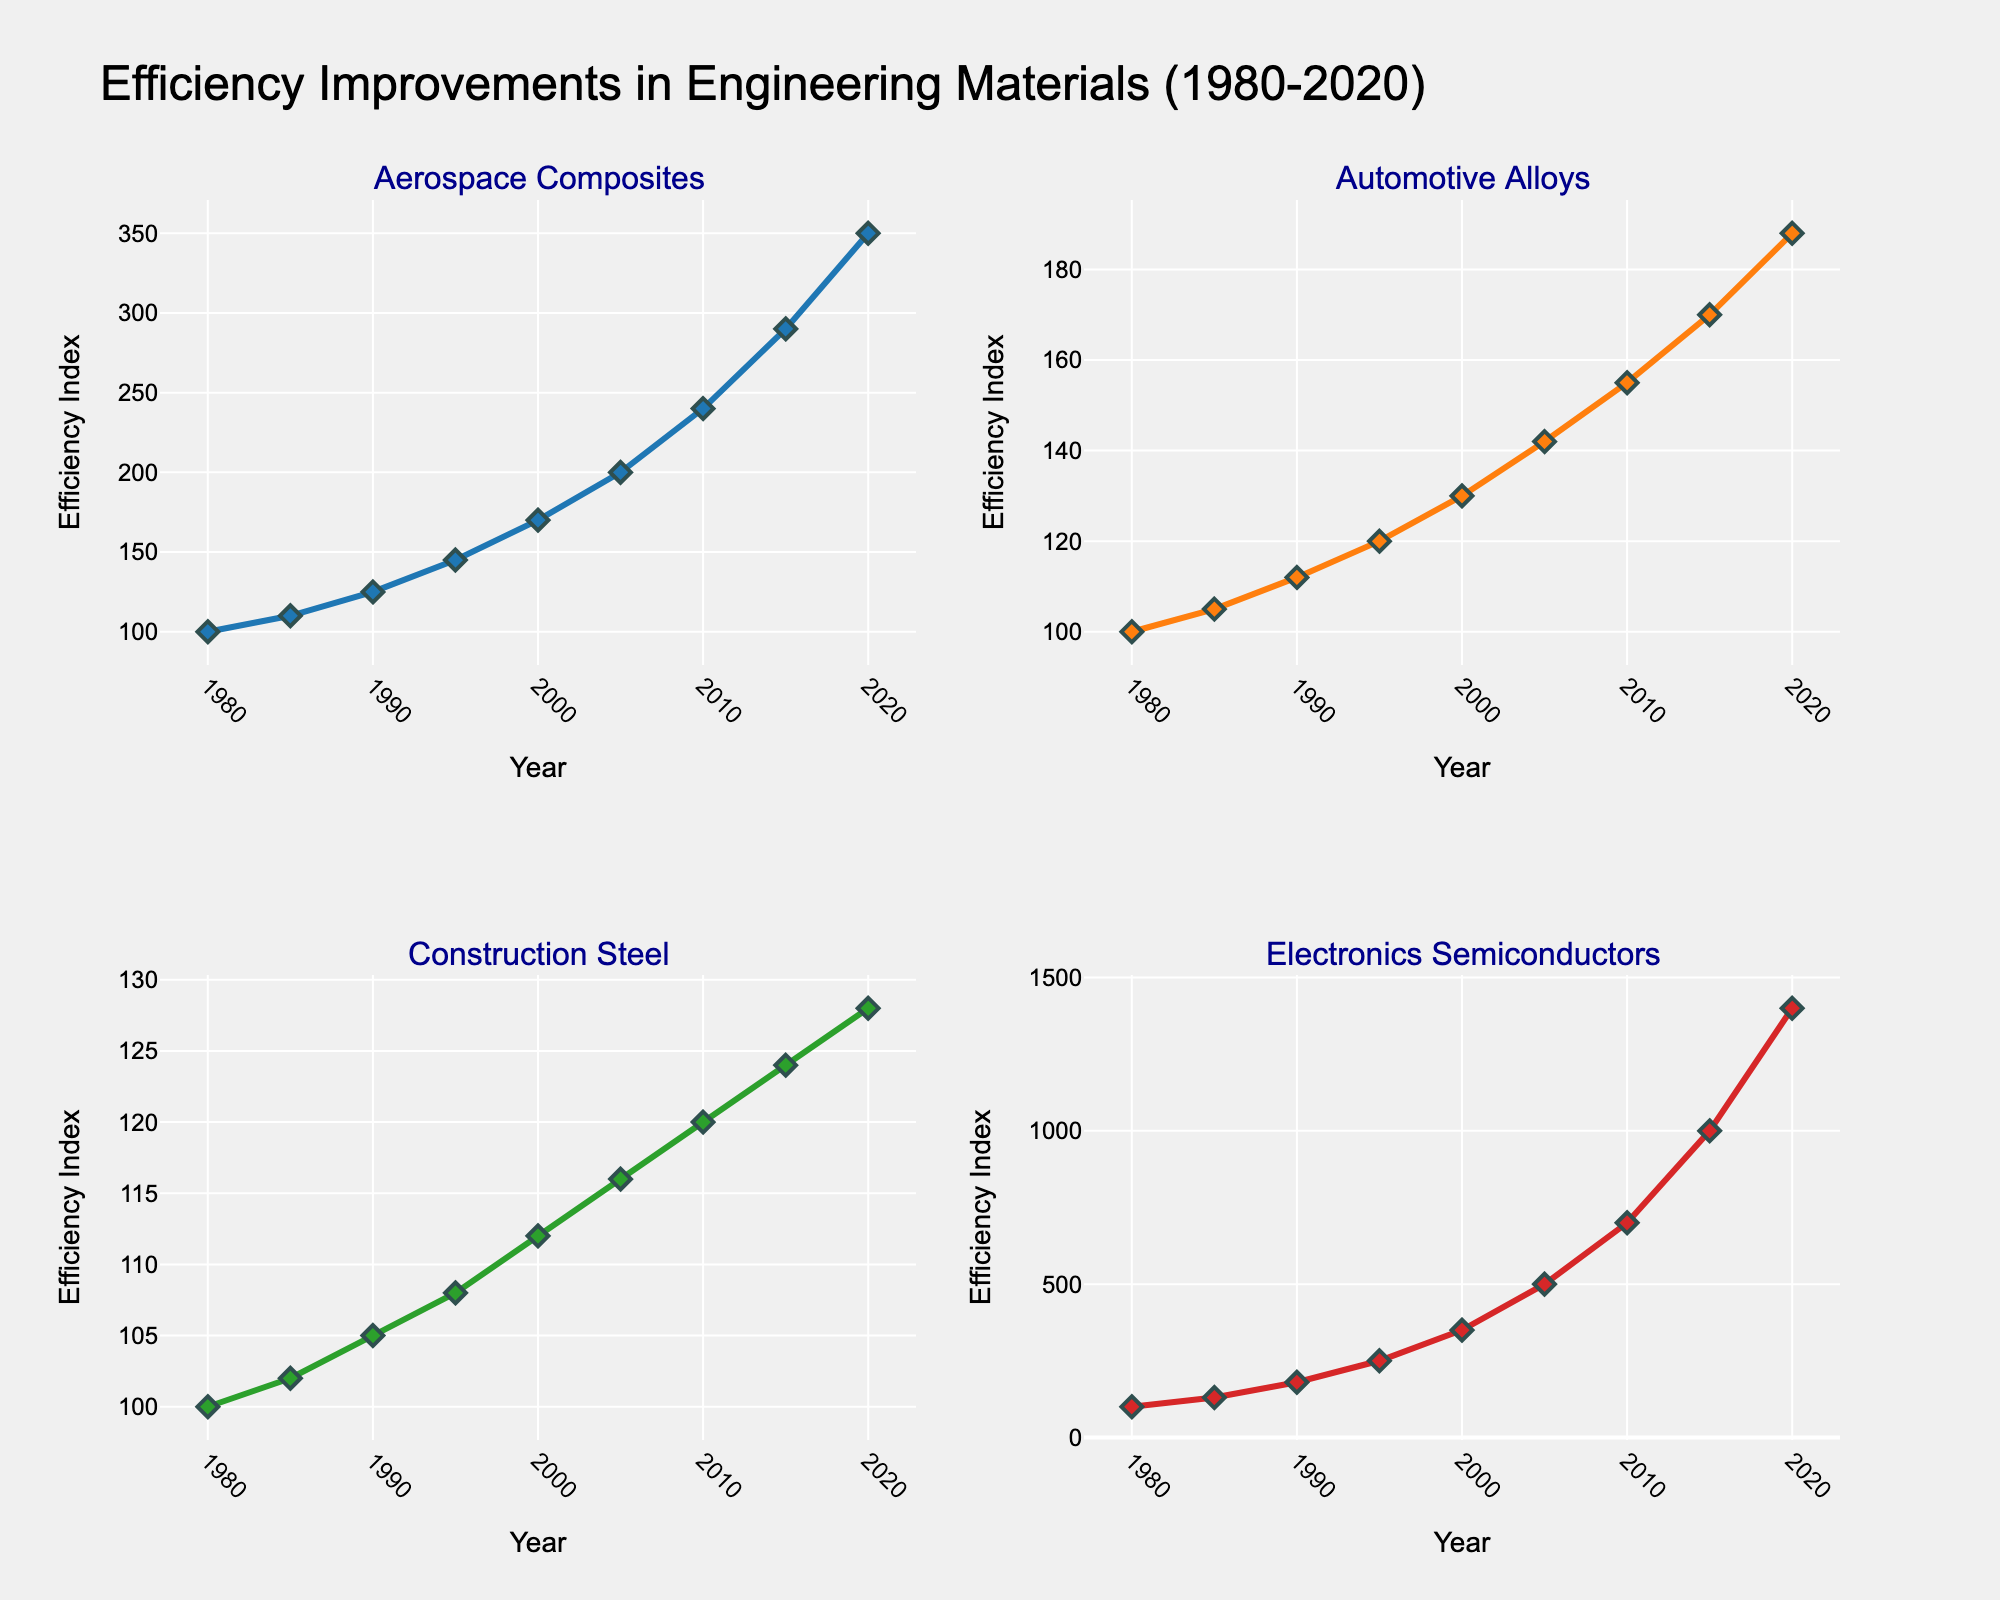What's the title of the figure? The title is usually located at the top-center of the figure. By looking at the figure's top, you can read the text that states the main topic of the chart.
Answer: Efficiency Improvements in Engineering Materials (1980-2020) How many subplots are included in the figure? Subplots are distinct sections within the figure, often separated by gridlines. Each subplot shows data for a different category. By counting these sections, we can determine their total number.
Answer: Four Which material shows the highest efficiency improvement in 2020? Each subplot has a different material represented, and the y-axis shows the efficiency index over time. By identifying the material with the highest y-value in 2020, we can find the one with the highest improvement.
Answer: Electronics Semiconductors What is the efficiency index of Aerospace Composites in the year 2000? To find this value, locate the subplot for Aerospace Composites and identify the data point corresponding to the year 2000 on the x-axis. The y-value of this point is the efficiency index.
Answer: 170 Compare the efficiency index of Automotive Alloys and Construction Steel in 1995. Which one is higher? Look at the subplots for both Automotive Alloys and Construction Steel. Identify the data points for the year 1995 and compare their y-values to see which one is higher.
Answer: Automotive Alloys What is the average efficiency improvement of Aerospace Composites from 2000 to 2020? Identify the efficiency indices of Aerospace Composites for the years 2000 and 2020. Compute their average by summing them up and dividing by two.
Answer: (170 + 350) / 2 = 260 In which year did Electronics Semiconductors surpass an efficiency index of 1000? In the subplot for Electronics Semiconductors, search for the year where the y-value first exceeds 1000.
Answer: 2015 How many different colors are used to represent the materials? Colors help distinguish different materials in the subplots. Count the distinct colors used for the lines and markers.
Answer: Four Which material had the least improvement in efficiency from 1980 to 2020? Calculate the difference in efficiency indices between 1980 and 2020 for each material. The material with the smallest difference has the least improvement.
Answer: Construction Steel 